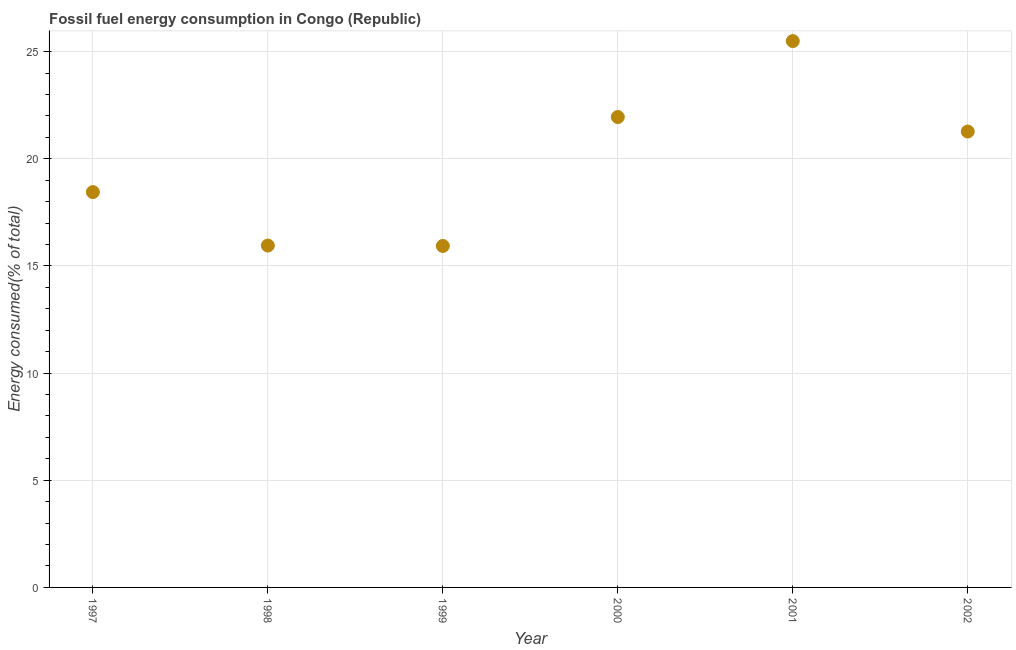What is the fossil fuel energy consumption in 1997?
Your answer should be very brief. 18.45. Across all years, what is the maximum fossil fuel energy consumption?
Offer a very short reply. 25.49. Across all years, what is the minimum fossil fuel energy consumption?
Give a very brief answer. 15.93. In which year was the fossil fuel energy consumption maximum?
Keep it short and to the point. 2001. What is the sum of the fossil fuel energy consumption?
Your response must be concise. 119.05. What is the difference between the fossil fuel energy consumption in 2001 and 2002?
Give a very brief answer. 4.22. What is the average fossil fuel energy consumption per year?
Offer a terse response. 19.84. What is the median fossil fuel energy consumption?
Offer a very short reply. 19.86. Do a majority of the years between 1999 and 2000 (inclusive) have fossil fuel energy consumption greater than 4 %?
Make the answer very short. Yes. What is the ratio of the fossil fuel energy consumption in 2001 to that in 2002?
Your answer should be compact. 1.2. Is the fossil fuel energy consumption in 2001 less than that in 2002?
Provide a succinct answer. No. Is the difference between the fossil fuel energy consumption in 1997 and 1998 greater than the difference between any two years?
Your answer should be very brief. No. What is the difference between the highest and the second highest fossil fuel energy consumption?
Provide a short and direct response. 3.54. Is the sum of the fossil fuel energy consumption in 2000 and 2002 greater than the maximum fossil fuel energy consumption across all years?
Offer a terse response. Yes. What is the difference between the highest and the lowest fossil fuel energy consumption?
Your answer should be very brief. 9.56. In how many years, is the fossil fuel energy consumption greater than the average fossil fuel energy consumption taken over all years?
Provide a succinct answer. 3. How many dotlines are there?
Make the answer very short. 1. How many years are there in the graph?
Ensure brevity in your answer.  6. Are the values on the major ticks of Y-axis written in scientific E-notation?
Your answer should be compact. No. Does the graph contain any zero values?
Ensure brevity in your answer.  No. What is the title of the graph?
Your response must be concise. Fossil fuel energy consumption in Congo (Republic). What is the label or title of the X-axis?
Provide a short and direct response. Year. What is the label or title of the Y-axis?
Your answer should be compact. Energy consumed(% of total). What is the Energy consumed(% of total) in 1997?
Offer a very short reply. 18.45. What is the Energy consumed(% of total) in 1998?
Your answer should be very brief. 15.95. What is the Energy consumed(% of total) in 1999?
Your response must be concise. 15.93. What is the Energy consumed(% of total) in 2000?
Your answer should be compact. 21.95. What is the Energy consumed(% of total) in 2001?
Provide a short and direct response. 25.49. What is the Energy consumed(% of total) in 2002?
Provide a short and direct response. 21.27. What is the difference between the Energy consumed(% of total) in 1997 and 1998?
Your answer should be very brief. 2.49. What is the difference between the Energy consumed(% of total) in 1997 and 1999?
Provide a short and direct response. 2.51. What is the difference between the Energy consumed(% of total) in 1997 and 2000?
Your response must be concise. -3.5. What is the difference between the Energy consumed(% of total) in 1997 and 2001?
Ensure brevity in your answer.  -7.05. What is the difference between the Energy consumed(% of total) in 1997 and 2002?
Your answer should be very brief. -2.83. What is the difference between the Energy consumed(% of total) in 1998 and 1999?
Your answer should be compact. 0.02. What is the difference between the Energy consumed(% of total) in 1998 and 2000?
Offer a terse response. -6. What is the difference between the Energy consumed(% of total) in 1998 and 2001?
Provide a short and direct response. -9.54. What is the difference between the Energy consumed(% of total) in 1998 and 2002?
Provide a short and direct response. -5.32. What is the difference between the Energy consumed(% of total) in 1999 and 2000?
Your answer should be very brief. -6.02. What is the difference between the Energy consumed(% of total) in 1999 and 2001?
Make the answer very short. -9.56. What is the difference between the Energy consumed(% of total) in 1999 and 2002?
Your answer should be very brief. -5.34. What is the difference between the Energy consumed(% of total) in 2000 and 2001?
Provide a short and direct response. -3.54. What is the difference between the Energy consumed(% of total) in 2000 and 2002?
Your response must be concise. 0.68. What is the difference between the Energy consumed(% of total) in 2001 and 2002?
Make the answer very short. 4.22. What is the ratio of the Energy consumed(% of total) in 1997 to that in 1998?
Give a very brief answer. 1.16. What is the ratio of the Energy consumed(% of total) in 1997 to that in 1999?
Your answer should be compact. 1.16. What is the ratio of the Energy consumed(% of total) in 1997 to that in 2000?
Offer a terse response. 0.84. What is the ratio of the Energy consumed(% of total) in 1997 to that in 2001?
Keep it short and to the point. 0.72. What is the ratio of the Energy consumed(% of total) in 1997 to that in 2002?
Provide a short and direct response. 0.87. What is the ratio of the Energy consumed(% of total) in 1998 to that in 1999?
Keep it short and to the point. 1. What is the ratio of the Energy consumed(% of total) in 1998 to that in 2000?
Your answer should be compact. 0.73. What is the ratio of the Energy consumed(% of total) in 1998 to that in 2001?
Your answer should be compact. 0.63. What is the ratio of the Energy consumed(% of total) in 1998 to that in 2002?
Provide a short and direct response. 0.75. What is the ratio of the Energy consumed(% of total) in 1999 to that in 2000?
Offer a very short reply. 0.73. What is the ratio of the Energy consumed(% of total) in 1999 to that in 2002?
Offer a terse response. 0.75. What is the ratio of the Energy consumed(% of total) in 2000 to that in 2001?
Keep it short and to the point. 0.86. What is the ratio of the Energy consumed(% of total) in 2000 to that in 2002?
Make the answer very short. 1.03. What is the ratio of the Energy consumed(% of total) in 2001 to that in 2002?
Your answer should be very brief. 1.2. 